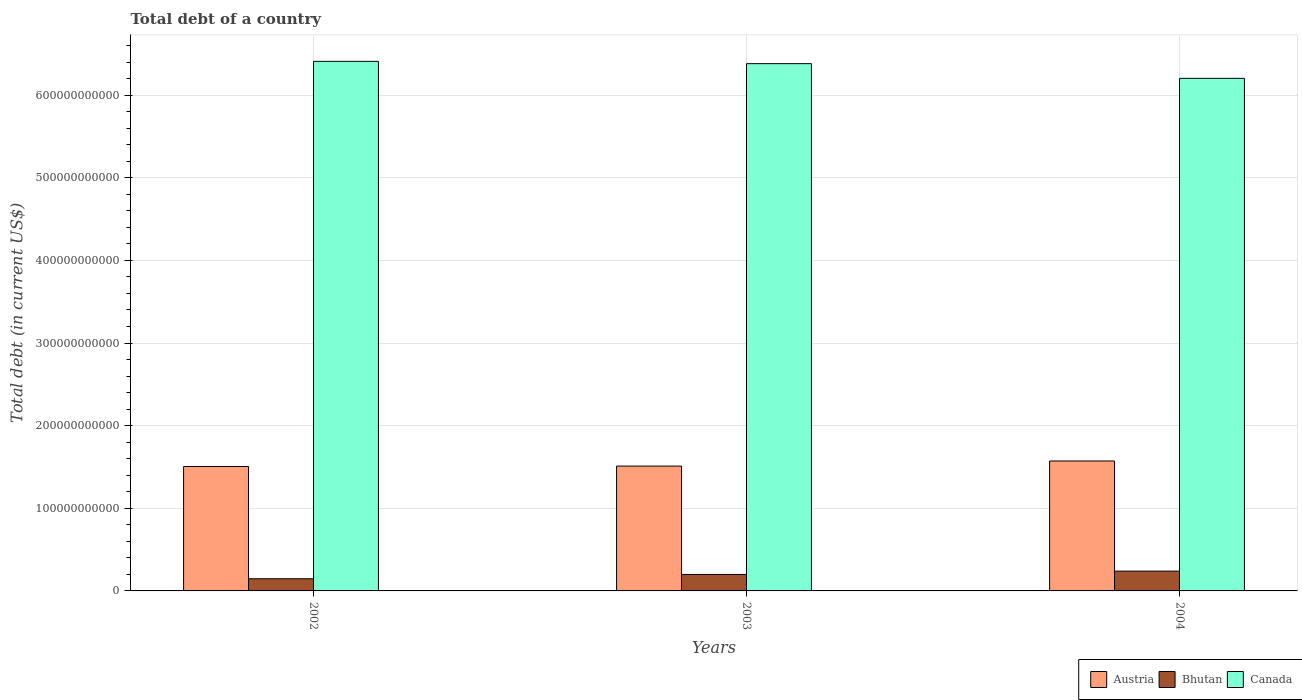How many groups of bars are there?
Make the answer very short. 3. Are the number of bars per tick equal to the number of legend labels?
Make the answer very short. Yes. How many bars are there on the 1st tick from the left?
Keep it short and to the point. 3. What is the label of the 1st group of bars from the left?
Offer a terse response. 2002. In how many cases, is the number of bars for a given year not equal to the number of legend labels?
Ensure brevity in your answer.  0. What is the debt in Austria in 2002?
Provide a short and direct response. 1.51e+11. Across all years, what is the maximum debt in Bhutan?
Offer a terse response. 2.40e+1. Across all years, what is the minimum debt in Austria?
Ensure brevity in your answer.  1.51e+11. In which year was the debt in Bhutan maximum?
Make the answer very short. 2004. In which year was the debt in Bhutan minimum?
Make the answer very short. 2002. What is the total debt in Austria in the graph?
Offer a very short reply. 4.59e+11. What is the difference between the debt in Austria in 2003 and that in 2004?
Your answer should be very brief. -6.16e+09. What is the difference between the debt in Canada in 2003 and the debt in Austria in 2004?
Provide a short and direct response. 4.81e+11. What is the average debt in Bhutan per year?
Your response must be concise. 1.95e+1. In the year 2004, what is the difference between the debt in Austria and debt in Bhutan?
Offer a terse response. 1.33e+11. In how many years, is the debt in Bhutan greater than 40000000000 US$?
Offer a very short reply. 0. What is the ratio of the debt in Austria in 2002 to that in 2004?
Your answer should be very brief. 0.96. Is the debt in Austria in 2003 less than that in 2004?
Provide a short and direct response. Yes. Is the difference between the debt in Austria in 2003 and 2004 greater than the difference between the debt in Bhutan in 2003 and 2004?
Ensure brevity in your answer.  No. What is the difference between the highest and the second highest debt in Bhutan?
Your answer should be compact. 4.03e+09. What is the difference between the highest and the lowest debt in Austria?
Provide a succinct answer. 6.68e+09. What does the 1st bar from the left in 2004 represents?
Your answer should be very brief. Austria. What does the 2nd bar from the right in 2003 represents?
Ensure brevity in your answer.  Bhutan. Is it the case that in every year, the sum of the debt in Austria and debt in Bhutan is greater than the debt in Canada?
Keep it short and to the point. No. How many bars are there?
Your answer should be very brief. 9. What is the difference between two consecutive major ticks on the Y-axis?
Your answer should be very brief. 1.00e+11. How are the legend labels stacked?
Offer a terse response. Horizontal. What is the title of the graph?
Ensure brevity in your answer.  Total debt of a country. Does "Sub-Saharan Africa (all income levels)" appear as one of the legend labels in the graph?
Your answer should be very brief. No. What is the label or title of the X-axis?
Ensure brevity in your answer.  Years. What is the label or title of the Y-axis?
Your answer should be very brief. Total debt (in current US$). What is the Total debt (in current US$) of Austria in 2002?
Provide a succinct answer. 1.51e+11. What is the Total debt (in current US$) of Bhutan in 2002?
Ensure brevity in your answer.  1.47e+1. What is the Total debt (in current US$) of Canada in 2002?
Make the answer very short. 6.41e+11. What is the Total debt (in current US$) in Austria in 2003?
Keep it short and to the point. 1.51e+11. What is the Total debt (in current US$) of Bhutan in 2003?
Provide a succinct answer. 1.99e+1. What is the Total debt (in current US$) of Canada in 2003?
Provide a succinct answer. 6.38e+11. What is the Total debt (in current US$) in Austria in 2004?
Your answer should be very brief. 1.57e+11. What is the Total debt (in current US$) of Bhutan in 2004?
Provide a succinct answer. 2.40e+1. What is the Total debt (in current US$) of Canada in 2004?
Your response must be concise. 6.20e+11. Across all years, what is the maximum Total debt (in current US$) in Austria?
Provide a short and direct response. 1.57e+11. Across all years, what is the maximum Total debt (in current US$) in Bhutan?
Provide a short and direct response. 2.40e+1. Across all years, what is the maximum Total debt (in current US$) of Canada?
Offer a terse response. 6.41e+11. Across all years, what is the minimum Total debt (in current US$) in Austria?
Your answer should be compact. 1.51e+11. Across all years, what is the minimum Total debt (in current US$) of Bhutan?
Keep it short and to the point. 1.47e+1. Across all years, what is the minimum Total debt (in current US$) in Canada?
Your answer should be compact. 6.20e+11. What is the total Total debt (in current US$) in Austria in the graph?
Provide a short and direct response. 4.59e+11. What is the total Total debt (in current US$) in Bhutan in the graph?
Provide a short and direct response. 5.86e+1. What is the total Total debt (in current US$) of Canada in the graph?
Ensure brevity in your answer.  1.90e+12. What is the difference between the Total debt (in current US$) in Austria in 2002 and that in 2003?
Offer a very short reply. -5.14e+08. What is the difference between the Total debt (in current US$) of Bhutan in 2002 and that in 2003?
Your answer should be compact. -5.22e+09. What is the difference between the Total debt (in current US$) in Canada in 2002 and that in 2003?
Your answer should be compact. 2.78e+09. What is the difference between the Total debt (in current US$) in Austria in 2002 and that in 2004?
Offer a very short reply. -6.68e+09. What is the difference between the Total debt (in current US$) in Bhutan in 2002 and that in 2004?
Offer a terse response. -9.24e+09. What is the difference between the Total debt (in current US$) in Canada in 2002 and that in 2004?
Provide a short and direct response. 2.05e+1. What is the difference between the Total debt (in current US$) in Austria in 2003 and that in 2004?
Your answer should be compact. -6.16e+09. What is the difference between the Total debt (in current US$) in Bhutan in 2003 and that in 2004?
Provide a succinct answer. -4.03e+09. What is the difference between the Total debt (in current US$) in Canada in 2003 and that in 2004?
Your answer should be very brief. 1.78e+1. What is the difference between the Total debt (in current US$) in Austria in 2002 and the Total debt (in current US$) in Bhutan in 2003?
Keep it short and to the point. 1.31e+11. What is the difference between the Total debt (in current US$) in Austria in 2002 and the Total debt (in current US$) in Canada in 2003?
Offer a terse response. -4.88e+11. What is the difference between the Total debt (in current US$) of Bhutan in 2002 and the Total debt (in current US$) of Canada in 2003?
Your answer should be very brief. -6.23e+11. What is the difference between the Total debt (in current US$) of Austria in 2002 and the Total debt (in current US$) of Bhutan in 2004?
Provide a short and direct response. 1.27e+11. What is the difference between the Total debt (in current US$) in Austria in 2002 and the Total debt (in current US$) in Canada in 2004?
Offer a very short reply. -4.70e+11. What is the difference between the Total debt (in current US$) in Bhutan in 2002 and the Total debt (in current US$) in Canada in 2004?
Give a very brief answer. -6.06e+11. What is the difference between the Total debt (in current US$) in Austria in 2003 and the Total debt (in current US$) in Bhutan in 2004?
Provide a succinct answer. 1.27e+11. What is the difference between the Total debt (in current US$) in Austria in 2003 and the Total debt (in current US$) in Canada in 2004?
Offer a very short reply. -4.69e+11. What is the difference between the Total debt (in current US$) of Bhutan in 2003 and the Total debt (in current US$) of Canada in 2004?
Provide a succinct answer. -6.00e+11. What is the average Total debt (in current US$) in Austria per year?
Your response must be concise. 1.53e+11. What is the average Total debt (in current US$) of Bhutan per year?
Ensure brevity in your answer.  1.95e+1. What is the average Total debt (in current US$) of Canada per year?
Provide a succinct answer. 6.33e+11. In the year 2002, what is the difference between the Total debt (in current US$) in Austria and Total debt (in current US$) in Bhutan?
Give a very brief answer. 1.36e+11. In the year 2002, what is the difference between the Total debt (in current US$) in Austria and Total debt (in current US$) in Canada?
Make the answer very short. -4.90e+11. In the year 2002, what is the difference between the Total debt (in current US$) of Bhutan and Total debt (in current US$) of Canada?
Give a very brief answer. -6.26e+11. In the year 2003, what is the difference between the Total debt (in current US$) in Austria and Total debt (in current US$) in Bhutan?
Offer a terse response. 1.31e+11. In the year 2003, what is the difference between the Total debt (in current US$) of Austria and Total debt (in current US$) of Canada?
Give a very brief answer. -4.87e+11. In the year 2003, what is the difference between the Total debt (in current US$) in Bhutan and Total debt (in current US$) in Canada?
Provide a succinct answer. -6.18e+11. In the year 2004, what is the difference between the Total debt (in current US$) in Austria and Total debt (in current US$) in Bhutan?
Your answer should be compact. 1.33e+11. In the year 2004, what is the difference between the Total debt (in current US$) in Austria and Total debt (in current US$) in Canada?
Provide a short and direct response. -4.63e+11. In the year 2004, what is the difference between the Total debt (in current US$) of Bhutan and Total debt (in current US$) of Canada?
Your answer should be compact. -5.96e+11. What is the ratio of the Total debt (in current US$) of Austria in 2002 to that in 2003?
Make the answer very short. 1. What is the ratio of the Total debt (in current US$) of Bhutan in 2002 to that in 2003?
Provide a short and direct response. 0.74. What is the ratio of the Total debt (in current US$) in Austria in 2002 to that in 2004?
Make the answer very short. 0.96. What is the ratio of the Total debt (in current US$) in Bhutan in 2002 to that in 2004?
Provide a short and direct response. 0.61. What is the ratio of the Total debt (in current US$) of Canada in 2002 to that in 2004?
Make the answer very short. 1.03. What is the ratio of the Total debt (in current US$) of Austria in 2003 to that in 2004?
Offer a terse response. 0.96. What is the ratio of the Total debt (in current US$) of Bhutan in 2003 to that in 2004?
Your answer should be compact. 0.83. What is the ratio of the Total debt (in current US$) of Canada in 2003 to that in 2004?
Offer a terse response. 1.03. What is the difference between the highest and the second highest Total debt (in current US$) in Austria?
Your answer should be very brief. 6.16e+09. What is the difference between the highest and the second highest Total debt (in current US$) in Bhutan?
Your answer should be compact. 4.03e+09. What is the difference between the highest and the second highest Total debt (in current US$) of Canada?
Offer a terse response. 2.78e+09. What is the difference between the highest and the lowest Total debt (in current US$) of Austria?
Offer a terse response. 6.68e+09. What is the difference between the highest and the lowest Total debt (in current US$) of Bhutan?
Your answer should be very brief. 9.24e+09. What is the difference between the highest and the lowest Total debt (in current US$) of Canada?
Your answer should be compact. 2.05e+1. 